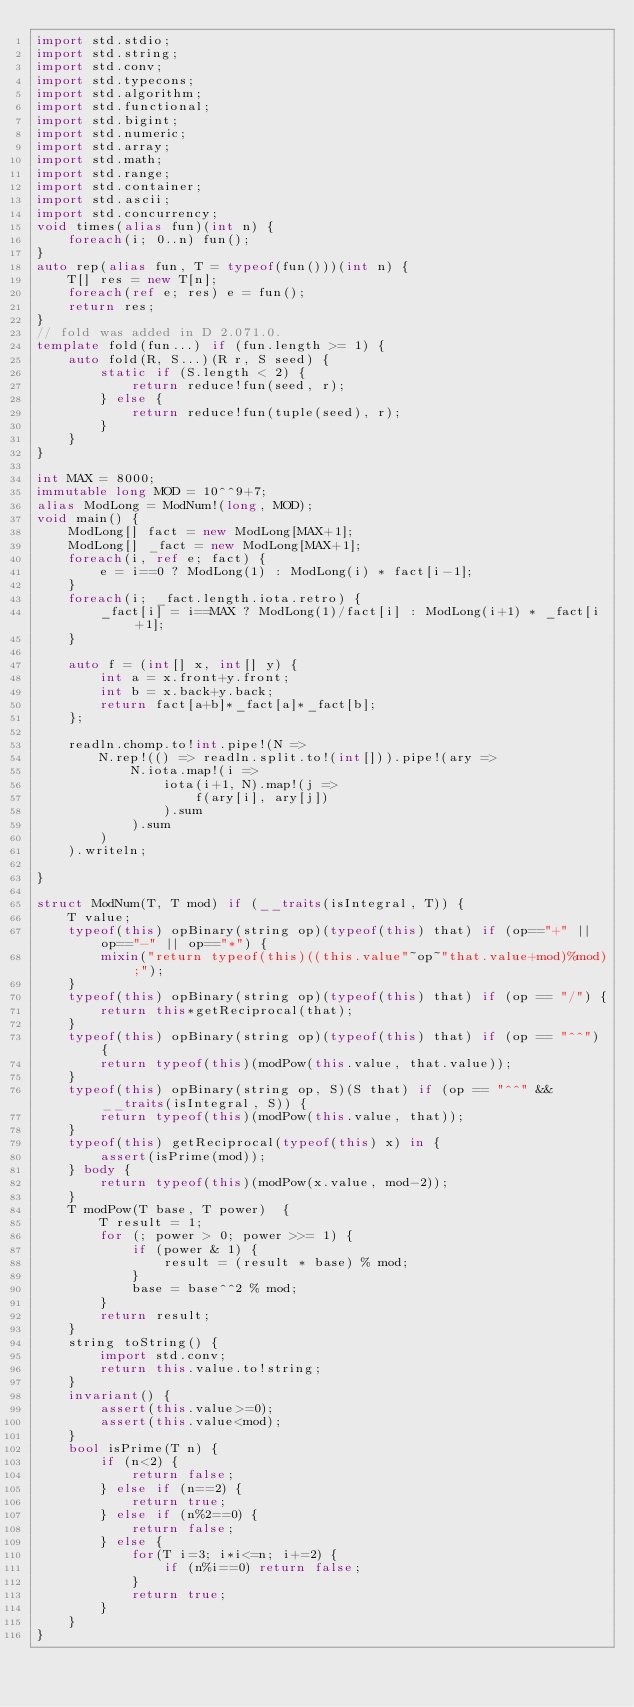Convert code to text. <code><loc_0><loc_0><loc_500><loc_500><_D_>import std.stdio;
import std.string;
import std.conv;
import std.typecons;
import std.algorithm;
import std.functional;
import std.bigint;
import std.numeric;
import std.array;
import std.math;
import std.range;
import std.container;
import std.ascii;
import std.concurrency;
void times(alias fun)(int n) {
    foreach(i; 0..n) fun();
}
auto rep(alias fun, T = typeof(fun()))(int n) {
    T[] res = new T[n];
    foreach(ref e; res) e = fun();
    return res;
}
// fold was added in D 2.071.0.
template fold(fun...) if (fun.length >= 1) {
    auto fold(R, S...)(R r, S seed) {
        static if (S.length < 2) {
            return reduce!fun(seed, r);
        } else {
            return reduce!fun(tuple(seed), r);
        }
    }
}
 
int MAX = 8000;
immutable long MOD = 10^^9+7;
alias ModLong = ModNum!(long, MOD);
void main() {
    ModLong[] fact = new ModLong[MAX+1];
    ModLong[] _fact = new ModLong[MAX+1];
    foreach(i, ref e; fact) {
        e = i==0 ? ModLong(1) : ModLong(i) * fact[i-1];
    }
    foreach(i; _fact.length.iota.retro) {
        _fact[i] = i==MAX ? ModLong(1)/fact[i] : ModLong(i+1) * _fact[i+1];
    }
 
    auto f = (int[] x, int[] y) {
        int a = x.front+y.front;
        int b = x.back+y.back;
        return fact[a+b]*_fact[a]*_fact[b];
    };
 
    readln.chomp.to!int.pipe!(N =>
        N.rep!(() => readln.split.to!(int[])).pipe!(ary =>
            N.iota.map!(i =>
                iota(i+1, N).map!(j =>
                    f(ary[i], ary[j])
                ).sum
            ).sum
        )
    ).writeln;
 
}
 
struct ModNum(T, T mod) if (__traits(isIntegral, T)) {
    T value;
    typeof(this) opBinary(string op)(typeof(this) that) if (op=="+" || op=="-" || op=="*") {
        mixin("return typeof(this)((this.value"~op~"that.value+mod)%mod);");
    }
    typeof(this) opBinary(string op)(typeof(this) that) if (op == "/") {
        return this*getReciprocal(that);
    }
    typeof(this) opBinary(string op)(typeof(this) that) if (op == "^^") {
        return typeof(this)(modPow(this.value, that.value));
    }
    typeof(this) opBinary(string op, S)(S that) if (op == "^^" && __traits(isIntegral, S)) {
        return typeof(this)(modPow(this.value, that));
    }
    typeof(this) getReciprocal(typeof(this) x) in {
        assert(isPrime(mod));
    } body {
        return typeof(this)(modPow(x.value, mod-2));
    }
    T modPow(T base, T power)  {
        T result = 1;
        for (; power > 0; power >>= 1) {
            if (power & 1) {
                result = (result * base) % mod;
            }
            base = base^^2 % mod;
        }
        return result;
    }
    string toString() {
        import std.conv;
        return this.value.to!string;
    }
    invariant() {
        assert(this.value>=0);
        assert(this.value<mod);
    }
    bool isPrime(T n) {
        if (n<2) {
            return false;
        } else if (n==2) {
            return true;
        } else if (n%2==0) {
            return false;
        } else {
            for(T i=3; i*i<=n; i+=2) {
                if (n%i==0) return false;
            }
            return true;
        }
    }
}</code> 